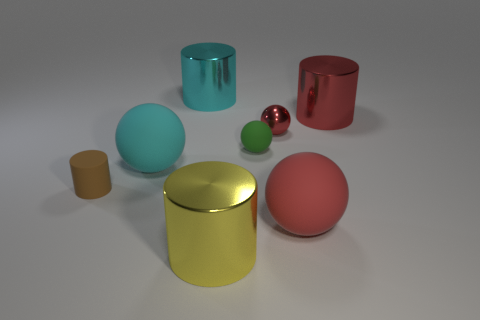Subtract all matte cylinders. How many cylinders are left? 3 Subtract all blue blocks. How many red balls are left? 2 Add 1 red cylinders. How many objects exist? 9 Subtract all cyan cylinders. How many cylinders are left? 3 Add 1 brown cylinders. How many brown cylinders are left? 2 Add 7 big red metallic objects. How many big red metallic objects exist? 8 Subtract 0 green cylinders. How many objects are left? 8 Subtract 2 balls. How many balls are left? 2 Subtract all purple cylinders. Subtract all red blocks. How many cylinders are left? 4 Subtract all small purple metallic spheres. Subtract all large matte spheres. How many objects are left? 6 